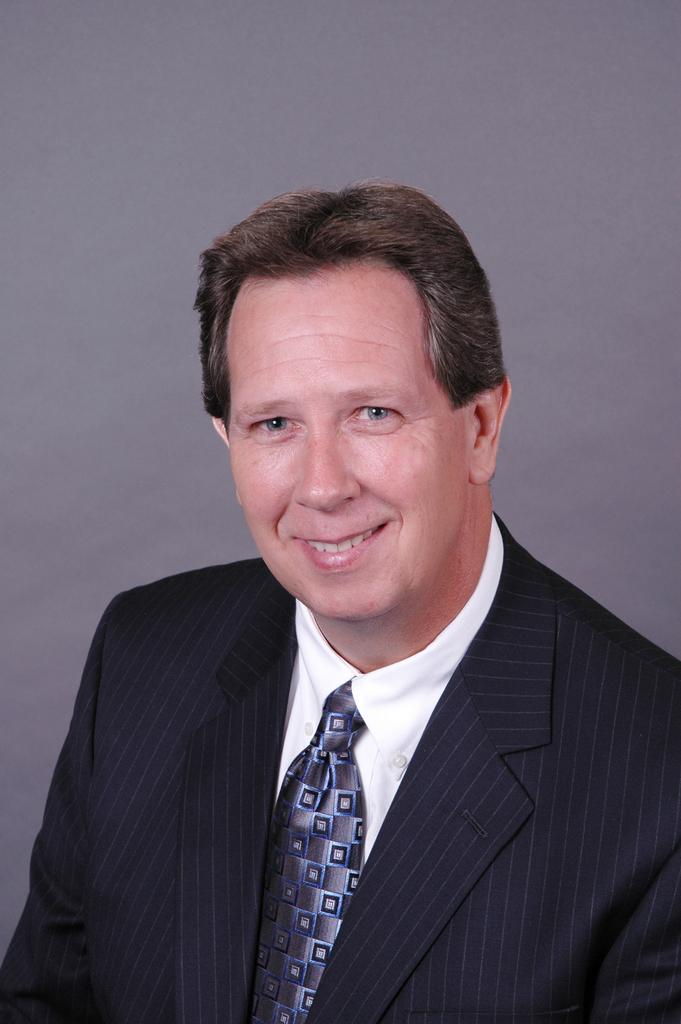Who is present in the image? There is a man in the image. What is the man's facial expression? The man is smiling. What color is the man's coat? The man is wearing a black coat. What type of clothing is the man wearing around his neck? A: The man is wearing a tie. What color is the man's shirt? The man is wearing a white shirt. What type of rod can be seen in the man's hand in the image? There is no rod present in the man's hand or in the image. 